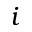Convert formula to latex. <formula><loc_0><loc_0><loc_500><loc_500>i</formula> 